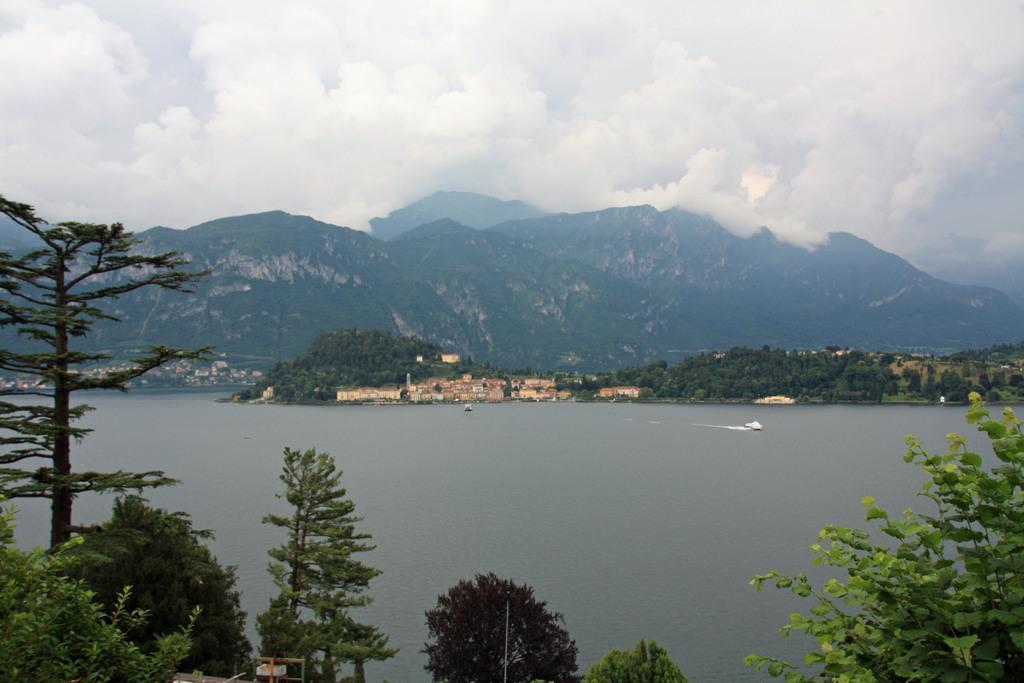Could you give a brief overview of what you see in this image? There is a water. On the sides there are trees. In the back there are trees, hills and sky with clouds. 